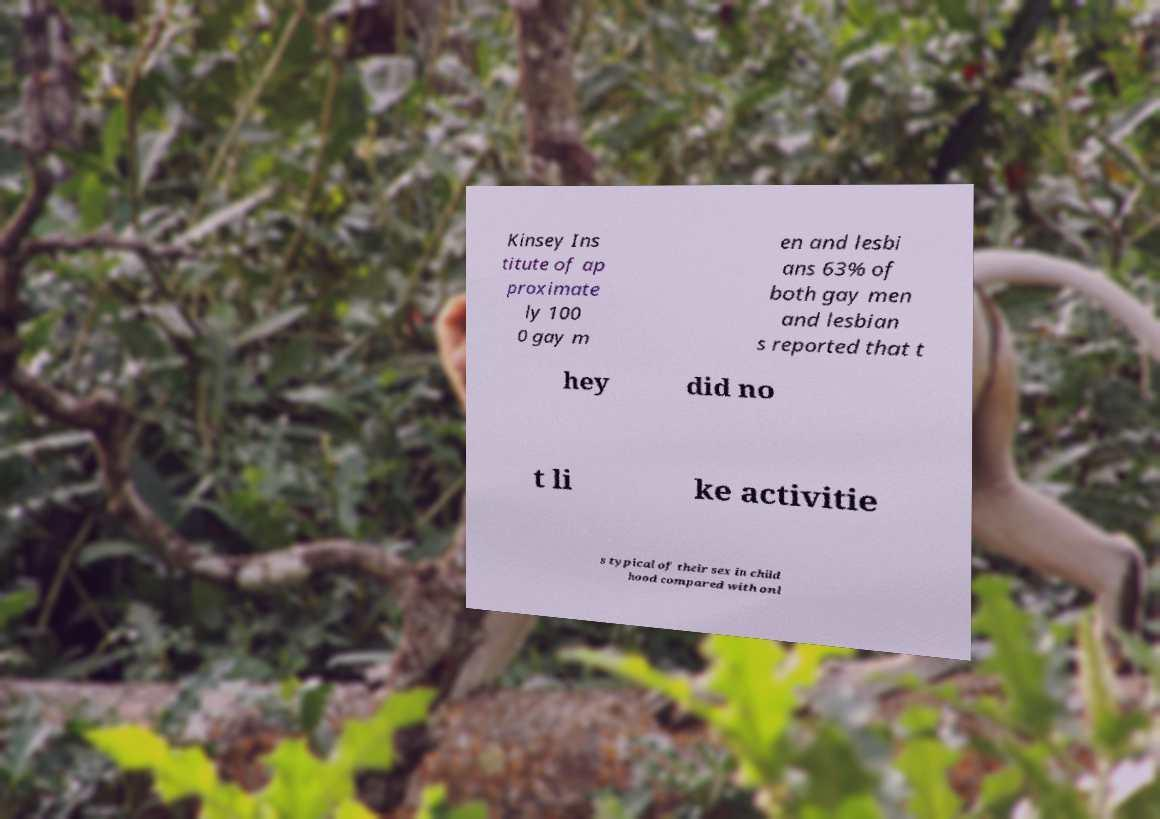What messages or text are displayed in this image? I need them in a readable, typed format. Kinsey Ins titute of ap proximate ly 100 0 gay m en and lesbi ans 63% of both gay men and lesbian s reported that t hey did no t li ke activitie s typical of their sex in child hood compared with onl 